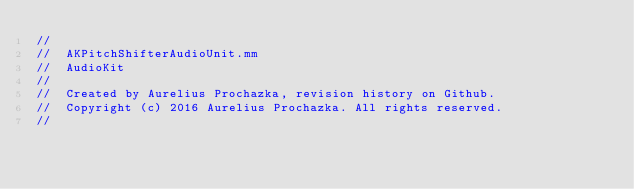Convert code to text. <code><loc_0><loc_0><loc_500><loc_500><_ObjectiveC_>//
//  AKPitchShifterAudioUnit.mm
//  AudioKit
//
//  Created by Aurelius Prochazka, revision history on Github.
//  Copyright (c) 2016 Aurelius Prochazka. All rights reserved.
//
</code> 